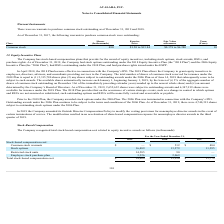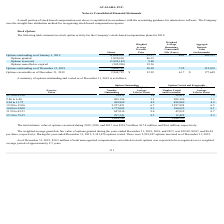From Avalara's financial document, What are the company's respective total stock-based compensation cost in 2017 and 2018? The document shows two values: $11,779 and $15,950 (in thousands). From the document: "Total stock-based compensation cost $ 34,400 $ 15,950 $ 11,779 stock-based compensation cost $ 34,400 $ 15,950 $ 11,779..." Also, What are the company's respective total stock-based compensation cost in 2018 and 2019? The document shows two values: $15,950 and $34,400 (in thousands). From the document: "Total stock-based compensation cost $ 34,400 $ 15,950 $ 11,779 Total stock-based compensation cost $ 34,400 $ 15,950 $ 11,779..." Also, What are the company's respective restricted stock units between 2017 to 2019? The document contains multiple relevant values: 0, 90, 14,585 (in thousands). From the document: "Restricted stock units 14,585 90 — Restricted stock units 14,585 90 — Restricted stock units 14,585 90 —..." Also, can you calculate: What is the percentage change in total stock based compensation cost between 2017 and 2018? To answer this question, I need to perform calculations using the financial data. The calculation is: (15,950 - 11,779)/11,779 , which equals 35.41 (percentage). This is based on the information: "Total stock-based compensation cost $ 34,400 $ 15,950 $ 11,779 stock-based compensation cost $ 34,400 $ 15,950 $ 11,779..." The key data points involved are: 11,779, 15,950. Also, can you calculate: What is the percentage change in total stock based compensation cost between 2018 and 2019? To answer this question, I need to perform calculations using the financial data. The calculation is: (34,400 - 15,950)/15,950 , which equals 115.67 (percentage). This is based on the information: "Total stock-based compensation cost $ 34,400 $ 15,950 $ 11,779 Total stock-based compensation cost $ 34,400 $ 15,950 $ 11,779..." The key data points involved are: 15,950, 34,400. Also, can you calculate: What is the change in common stock warrants between 2017 and 2018? Based on the calculation: 512 - 484 , the result is 28 (in thousands). This is based on the information: "Common stock warrants $ — $ 512 $ 484 Common stock warrants $ — $ 512 $ 484..." The key data points involved are: 484, 512. 